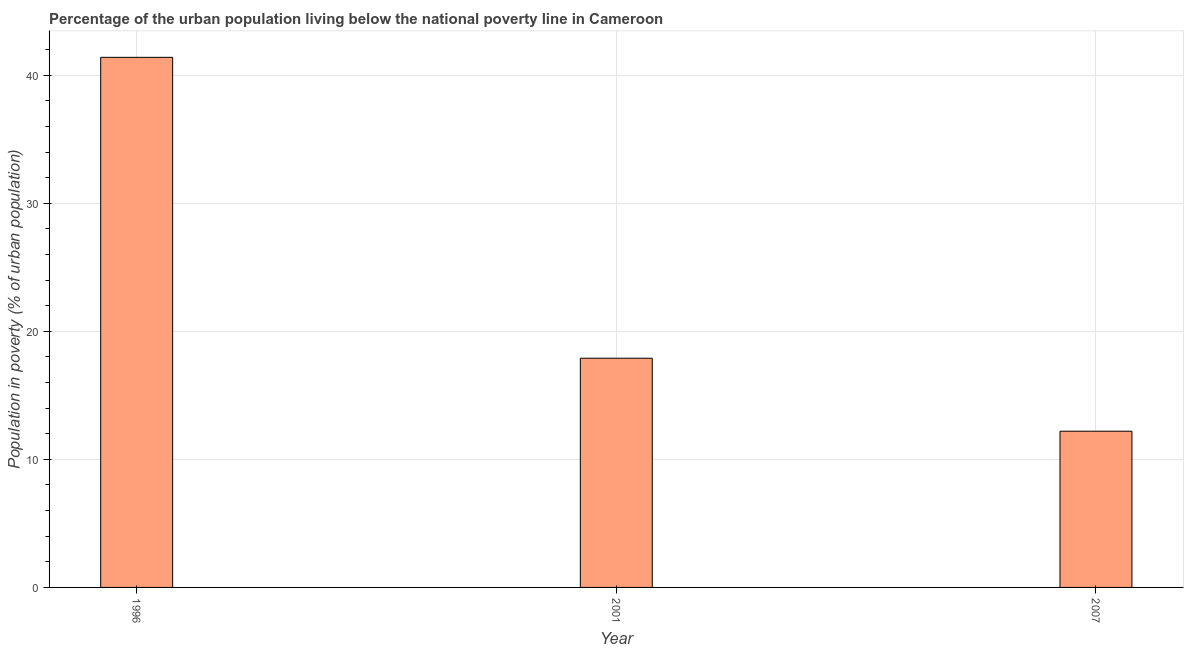Does the graph contain any zero values?
Provide a succinct answer. No. Does the graph contain grids?
Provide a short and direct response. Yes. What is the title of the graph?
Offer a very short reply. Percentage of the urban population living below the national poverty line in Cameroon. What is the label or title of the Y-axis?
Make the answer very short. Population in poverty (% of urban population). What is the percentage of urban population living below poverty line in 2001?
Provide a short and direct response. 17.9. Across all years, what is the maximum percentage of urban population living below poverty line?
Ensure brevity in your answer.  41.4. What is the sum of the percentage of urban population living below poverty line?
Make the answer very short. 71.5. What is the average percentage of urban population living below poverty line per year?
Your answer should be compact. 23.83. What is the median percentage of urban population living below poverty line?
Give a very brief answer. 17.9. In how many years, is the percentage of urban population living below poverty line greater than 28 %?
Provide a short and direct response. 1. Do a majority of the years between 2007 and 1996 (inclusive) have percentage of urban population living below poverty line greater than 30 %?
Provide a short and direct response. Yes. What is the ratio of the percentage of urban population living below poverty line in 2001 to that in 2007?
Ensure brevity in your answer.  1.47. Is the sum of the percentage of urban population living below poverty line in 1996 and 2007 greater than the maximum percentage of urban population living below poverty line across all years?
Give a very brief answer. Yes. What is the difference between the highest and the lowest percentage of urban population living below poverty line?
Your answer should be compact. 29.2. In how many years, is the percentage of urban population living below poverty line greater than the average percentage of urban population living below poverty line taken over all years?
Keep it short and to the point. 1. Are the values on the major ticks of Y-axis written in scientific E-notation?
Offer a very short reply. No. What is the Population in poverty (% of urban population) of 1996?
Provide a short and direct response. 41.4. What is the Population in poverty (% of urban population) of 2001?
Offer a very short reply. 17.9. What is the difference between the Population in poverty (% of urban population) in 1996 and 2001?
Provide a succinct answer. 23.5. What is the difference between the Population in poverty (% of urban population) in 1996 and 2007?
Make the answer very short. 29.2. What is the difference between the Population in poverty (% of urban population) in 2001 and 2007?
Offer a terse response. 5.7. What is the ratio of the Population in poverty (% of urban population) in 1996 to that in 2001?
Provide a succinct answer. 2.31. What is the ratio of the Population in poverty (% of urban population) in 1996 to that in 2007?
Offer a very short reply. 3.39. What is the ratio of the Population in poverty (% of urban population) in 2001 to that in 2007?
Keep it short and to the point. 1.47. 